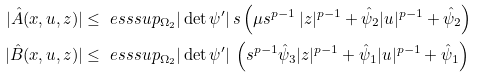<formula> <loc_0><loc_0><loc_500><loc_500>| \hat { A } ( x , u , z ) | & \leq \ e s s s u p _ { \Omega _ { 2 } } | \det \psi ^ { \prime } | \, s \left ( \mu s ^ { p - 1 } \, | z | ^ { p - 1 } + \hat { \psi } _ { 2 } | u | ^ { p - 1 } + \hat { \psi } _ { 2 } \right ) \\ | \hat { B } ( x , u , z ) | & \leq \ e s s s u p _ { \Omega _ { 2 } } | \det \psi ^ { \prime } | \, \left ( s ^ { p - 1 } \hat { \psi } _ { 3 } | z | ^ { p - 1 } + \hat { \psi } _ { 1 } | u | ^ { p - 1 } + \hat { \psi } _ { 1 } \right )</formula> 